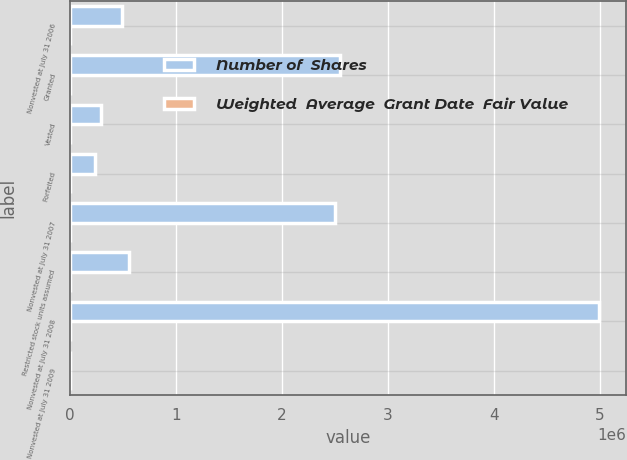<chart> <loc_0><loc_0><loc_500><loc_500><stacked_bar_chart><ecel><fcel>Nonvested at July 31 2006<fcel>Granted<fcel>Vested<fcel>Forfeited<fcel>Nonvested at July 31 2007<fcel>Restricted stock units assumed<fcel>Nonvested at July 31 2008<fcel>Nonvested at July 31 2009<nl><fcel>Number of  Shares<fcel>488236<fcel>2.54834e+06<fcel>292401<fcel>239489<fcel>2.50469e+06<fcel>561887<fcel>4.99733e+06<fcel>30.59<nl><fcel>Weighted  Average  Grant Date  Fair Value<fcel>23.03<fcel>30.59<fcel>23.73<fcel>30.54<fcel>29.88<fcel>29.78<fcel>29.29<fcel>27.06<nl></chart> 